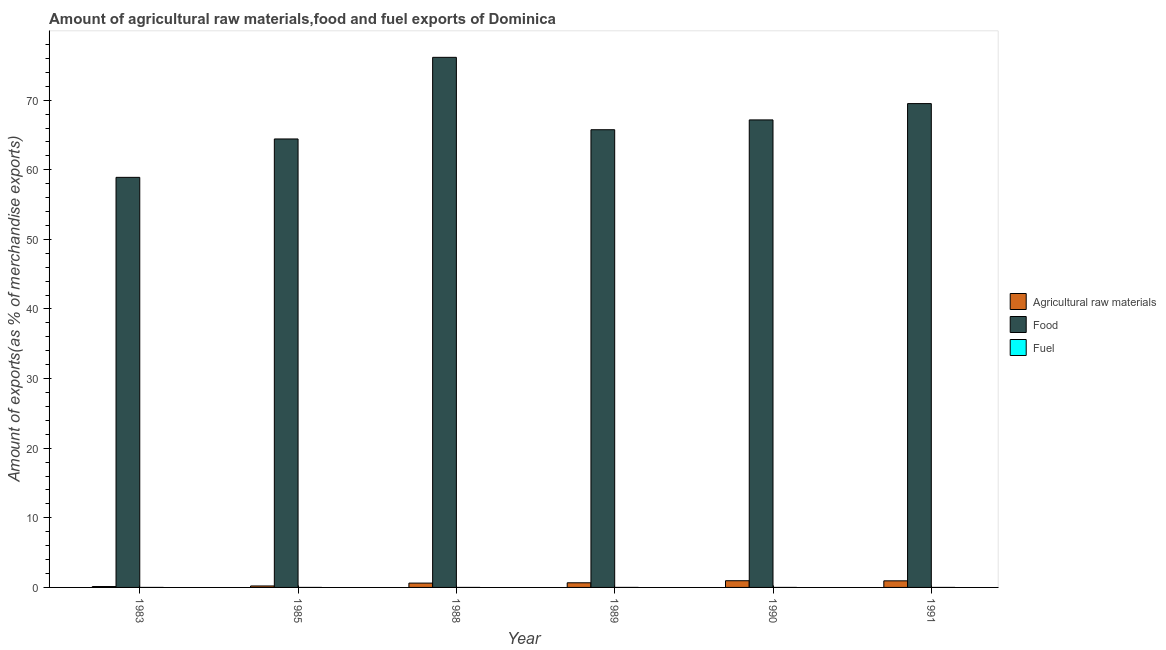How many different coloured bars are there?
Your response must be concise. 3. How many groups of bars are there?
Offer a terse response. 6. Are the number of bars on each tick of the X-axis equal?
Keep it short and to the point. Yes. How many bars are there on the 1st tick from the right?
Your answer should be compact. 3. What is the label of the 4th group of bars from the left?
Provide a short and direct response. 1989. What is the percentage of food exports in 1985?
Your answer should be compact. 64.43. Across all years, what is the maximum percentage of fuel exports?
Ensure brevity in your answer.  0. Across all years, what is the minimum percentage of fuel exports?
Offer a terse response. 3.92247456525302e-6. In which year was the percentage of fuel exports maximum?
Provide a short and direct response. 1989. In which year was the percentage of food exports minimum?
Your response must be concise. 1983. What is the total percentage of fuel exports in the graph?
Keep it short and to the point. 0. What is the difference between the percentage of food exports in 1983 and that in 1985?
Offer a terse response. -5.51. What is the difference between the percentage of raw materials exports in 1985 and the percentage of fuel exports in 1988?
Your answer should be very brief. -0.41. What is the average percentage of food exports per year?
Offer a terse response. 66.99. What is the ratio of the percentage of food exports in 1985 to that in 1991?
Make the answer very short. 0.93. What is the difference between the highest and the second highest percentage of raw materials exports?
Offer a terse response. 0.02. What is the difference between the highest and the lowest percentage of raw materials exports?
Give a very brief answer. 0.83. In how many years, is the percentage of raw materials exports greater than the average percentage of raw materials exports taken over all years?
Your answer should be very brief. 4. Is the sum of the percentage of raw materials exports in 1985 and 1989 greater than the maximum percentage of food exports across all years?
Your answer should be very brief. No. What does the 3rd bar from the left in 1991 represents?
Provide a succinct answer. Fuel. What does the 2nd bar from the right in 1988 represents?
Your answer should be compact. Food. Is it the case that in every year, the sum of the percentage of raw materials exports and percentage of food exports is greater than the percentage of fuel exports?
Your response must be concise. Yes. What is the difference between two consecutive major ticks on the Y-axis?
Give a very brief answer. 10. Does the graph contain grids?
Your answer should be compact. No. What is the title of the graph?
Ensure brevity in your answer.  Amount of agricultural raw materials,food and fuel exports of Dominica. What is the label or title of the Y-axis?
Give a very brief answer. Amount of exports(as % of merchandise exports). What is the Amount of exports(as % of merchandise exports) in Agricultural raw materials in 1983?
Ensure brevity in your answer.  0.13. What is the Amount of exports(as % of merchandise exports) in Food in 1983?
Your answer should be very brief. 58.91. What is the Amount of exports(as % of merchandise exports) of Fuel in 1983?
Your answer should be very brief. 0. What is the Amount of exports(as % of merchandise exports) of Agricultural raw materials in 1985?
Ensure brevity in your answer.  0.21. What is the Amount of exports(as % of merchandise exports) of Food in 1985?
Make the answer very short. 64.43. What is the Amount of exports(as % of merchandise exports) of Fuel in 1985?
Your answer should be very brief. 3.67117277885959e-5. What is the Amount of exports(as % of merchandise exports) in Agricultural raw materials in 1988?
Offer a terse response. 0.62. What is the Amount of exports(as % of merchandise exports) in Food in 1988?
Your answer should be very brief. 76.16. What is the Amount of exports(as % of merchandise exports) of Fuel in 1988?
Give a very brief answer. 0. What is the Amount of exports(as % of merchandise exports) in Agricultural raw materials in 1989?
Provide a succinct answer. 0.67. What is the Amount of exports(as % of merchandise exports) of Food in 1989?
Provide a succinct answer. 65.75. What is the Amount of exports(as % of merchandise exports) of Fuel in 1989?
Give a very brief answer. 0. What is the Amount of exports(as % of merchandise exports) of Agricultural raw materials in 1990?
Provide a short and direct response. 0.96. What is the Amount of exports(as % of merchandise exports) of Food in 1990?
Ensure brevity in your answer.  67.17. What is the Amount of exports(as % of merchandise exports) of Fuel in 1990?
Provide a short and direct response. 0. What is the Amount of exports(as % of merchandise exports) of Agricultural raw materials in 1991?
Your answer should be compact. 0.95. What is the Amount of exports(as % of merchandise exports) of Food in 1991?
Ensure brevity in your answer.  69.51. What is the Amount of exports(as % of merchandise exports) of Fuel in 1991?
Ensure brevity in your answer.  3.92247456525302e-6. Across all years, what is the maximum Amount of exports(as % of merchandise exports) of Agricultural raw materials?
Offer a terse response. 0.96. Across all years, what is the maximum Amount of exports(as % of merchandise exports) of Food?
Provide a succinct answer. 76.16. Across all years, what is the maximum Amount of exports(as % of merchandise exports) in Fuel?
Offer a terse response. 0. Across all years, what is the minimum Amount of exports(as % of merchandise exports) in Agricultural raw materials?
Keep it short and to the point. 0.13. Across all years, what is the minimum Amount of exports(as % of merchandise exports) of Food?
Provide a short and direct response. 58.91. Across all years, what is the minimum Amount of exports(as % of merchandise exports) in Fuel?
Your answer should be compact. 3.92247456525302e-6. What is the total Amount of exports(as % of merchandise exports) in Agricultural raw materials in the graph?
Keep it short and to the point. 3.54. What is the total Amount of exports(as % of merchandise exports) in Food in the graph?
Ensure brevity in your answer.  401.92. What is the total Amount of exports(as % of merchandise exports) of Fuel in the graph?
Offer a very short reply. 0. What is the difference between the Amount of exports(as % of merchandise exports) in Agricultural raw materials in 1983 and that in 1985?
Your answer should be very brief. -0.08. What is the difference between the Amount of exports(as % of merchandise exports) of Food in 1983 and that in 1985?
Give a very brief answer. -5.51. What is the difference between the Amount of exports(as % of merchandise exports) in Agricultural raw materials in 1983 and that in 1988?
Keep it short and to the point. -0.49. What is the difference between the Amount of exports(as % of merchandise exports) of Food in 1983 and that in 1988?
Offer a very short reply. -17.24. What is the difference between the Amount of exports(as % of merchandise exports) in Fuel in 1983 and that in 1988?
Give a very brief answer. 0. What is the difference between the Amount of exports(as % of merchandise exports) in Agricultural raw materials in 1983 and that in 1989?
Provide a short and direct response. -0.54. What is the difference between the Amount of exports(as % of merchandise exports) of Food in 1983 and that in 1989?
Your response must be concise. -6.84. What is the difference between the Amount of exports(as % of merchandise exports) of Fuel in 1983 and that in 1989?
Ensure brevity in your answer.  -0. What is the difference between the Amount of exports(as % of merchandise exports) in Agricultural raw materials in 1983 and that in 1990?
Offer a terse response. -0.83. What is the difference between the Amount of exports(as % of merchandise exports) of Food in 1983 and that in 1990?
Offer a terse response. -8.25. What is the difference between the Amount of exports(as % of merchandise exports) of Agricultural raw materials in 1983 and that in 1991?
Provide a succinct answer. -0.82. What is the difference between the Amount of exports(as % of merchandise exports) of Food in 1983 and that in 1991?
Offer a terse response. -10.59. What is the difference between the Amount of exports(as % of merchandise exports) in Agricultural raw materials in 1985 and that in 1988?
Give a very brief answer. -0.41. What is the difference between the Amount of exports(as % of merchandise exports) of Food in 1985 and that in 1988?
Your answer should be very brief. -11.73. What is the difference between the Amount of exports(as % of merchandise exports) of Fuel in 1985 and that in 1988?
Give a very brief answer. -0. What is the difference between the Amount of exports(as % of merchandise exports) in Agricultural raw materials in 1985 and that in 1989?
Your answer should be compact. -0.46. What is the difference between the Amount of exports(as % of merchandise exports) of Food in 1985 and that in 1989?
Provide a succinct answer. -1.33. What is the difference between the Amount of exports(as % of merchandise exports) of Fuel in 1985 and that in 1989?
Offer a very short reply. -0. What is the difference between the Amount of exports(as % of merchandise exports) in Agricultural raw materials in 1985 and that in 1990?
Make the answer very short. -0.75. What is the difference between the Amount of exports(as % of merchandise exports) of Food in 1985 and that in 1990?
Provide a succinct answer. -2.74. What is the difference between the Amount of exports(as % of merchandise exports) of Fuel in 1985 and that in 1990?
Your answer should be compact. -0. What is the difference between the Amount of exports(as % of merchandise exports) of Agricultural raw materials in 1985 and that in 1991?
Offer a very short reply. -0.74. What is the difference between the Amount of exports(as % of merchandise exports) in Food in 1985 and that in 1991?
Offer a very short reply. -5.08. What is the difference between the Amount of exports(as % of merchandise exports) in Agricultural raw materials in 1988 and that in 1989?
Make the answer very short. -0.05. What is the difference between the Amount of exports(as % of merchandise exports) of Food in 1988 and that in 1989?
Provide a short and direct response. 10.4. What is the difference between the Amount of exports(as % of merchandise exports) in Fuel in 1988 and that in 1989?
Your response must be concise. -0. What is the difference between the Amount of exports(as % of merchandise exports) in Agricultural raw materials in 1988 and that in 1990?
Ensure brevity in your answer.  -0.34. What is the difference between the Amount of exports(as % of merchandise exports) in Food in 1988 and that in 1990?
Your answer should be very brief. 8.99. What is the difference between the Amount of exports(as % of merchandise exports) of Fuel in 1988 and that in 1990?
Provide a short and direct response. 0. What is the difference between the Amount of exports(as % of merchandise exports) of Agricultural raw materials in 1988 and that in 1991?
Ensure brevity in your answer.  -0.32. What is the difference between the Amount of exports(as % of merchandise exports) in Food in 1988 and that in 1991?
Offer a terse response. 6.65. What is the difference between the Amount of exports(as % of merchandise exports) of Agricultural raw materials in 1989 and that in 1990?
Provide a succinct answer. -0.3. What is the difference between the Amount of exports(as % of merchandise exports) in Food in 1989 and that in 1990?
Your answer should be very brief. -1.41. What is the difference between the Amount of exports(as % of merchandise exports) in Fuel in 1989 and that in 1990?
Your response must be concise. 0. What is the difference between the Amount of exports(as % of merchandise exports) of Agricultural raw materials in 1989 and that in 1991?
Offer a very short reply. -0.28. What is the difference between the Amount of exports(as % of merchandise exports) in Food in 1989 and that in 1991?
Your answer should be compact. -3.75. What is the difference between the Amount of exports(as % of merchandise exports) in Fuel in 1989 and that in 1991?
Your answer should be compact. 0. What is the difference between the Amount of exports(as % of merchandise exports) of Agricultural raw materials in 1990 and that in 1991?
Make the answer very short. 0.02. What is the difference between the Amount of exports(as % of merchandise exports) of Food in 1990 and that in 1991?
Provide a succinct answer. -2.34. What is the difference between the Amount of exports(as % of merchandise exports) in Agricultural raw materials in 1983 and the Amount of exports(as % of merchandise exports) in Food in 1985?
Make the answer very short. -64.3. What is the difference between the Amount of exports(as % of merchandise exports) of Agricultural raw materials in 1983 and the Amount of exports(as % of merchandise exports) of Fuel in 1985?
Ensure brevity in your answer.  0.13. What is the difference between the Amount of exports(as % of merchandise exports) in Food in 1983 and the Amount of exports(as % of merchandise exports) in Fuel in 1985?
Offer a terse response. 58.91. What is the difference between the Amount of exports(as % of merchandise exports) in Agricultural raw materials in 1983 and the Amount of exports(as % of merchandise exports) in Food in 1988?
Offer a terse response. -76.02. What is the difference between the Amount of exports(as % of merchandise exports) in Agricultural raw materials in 1983 and the Amount of exports(as % of merchandise exports) in Fuel in 1988?
Your answer should be compact. 0.13. What is the difference between the Amount of exports(as % of merchandise exports) in Food in 1983 and the Amount of exports(as % of merchandise exports) in Fuel in 1988?
Ensure brevity in your answer.  58.91. What is the difference between the Amount of exports(as % of merchandise exports) in Agricultural raw materials in 1983 and the Amount of exports(as % of merchandise exports) in Food in 1989?
Give a very brief answer. -65.62. What is the difference between the Amount of exports(as % of merchandise exports) in Agricultural raw materials in 1983 and the Amount of exports(as % of merchandise exports) in Fuel in 1989?
Ensure brevity in your answer.  0.13. What is the difference between the Amount of exports(as % of merchandise exports) of Food in 1983 and the Amount of exports(as % of merchandise exports) of Fuel in 1989?
Your answer should be very brief. 58.91. What is the difference between the Amount of exports(as % of merchandise exports) of Agricultural raw materials in 1983 and the Amount of exports(as % of merchandise exports) of Food in 1990?
Your answer should be very brief. -67.03. What is the difference between the Amount of exports(as % of merchandise exports) in Agricultural raw materials in 1983 and the Amount of exports(as % of merchandise exports) in Fuel in 1990?
Offer a very short reply. 0.13. What is the difference between the Amount of exports(as % of merchandise exports) of Food in 1983 and the Amount of exports(as % of merchandise exports) of Fuel in 1990?
Make the answer very short. 58.91. What is the difference between the Amount of exports(as % of merchandise exports) of Agricultural raw materials in 1983 and the Amount of exports(as % of merchandise exports) of Food in 1991?
Give a very brief answer. -69.38. What is the difference between the Amount of exports(as % of merchandise exports) in Agricultural raw materials in 1983 and the Amount of exports(as % of merchandise exports) in Fuel in 1991?
Give a very brief answer. 0.13. What is the difference between the Amount of exports(as % of merchandise exports) of Food in 1983 and the Amount of exports(as % of merchandise exports) of Fuel in 1991?
Provide a succinct answer. 58.91. What is the difference between the Amount of exports(as % of merchandise exports) in Agricultural raw materials in 1985 and the Amount of exports(as % of merchandise exports) in Food in 1988?
Provide a short and direct response. -75.94. What is the difference between the Amount of exports(as % of merchandise exports) of Agricultural raw materials in 1985 and the Amount of exports(as % of merchandise exports) of Fuel in 1988?
Make the answer very short. 0.21. What is the difference between the Amount of exports(as % of merchandise exports) of Food in 1985 and the Amount of exports(as % of merchandise exports) of Fuel in 1988?
Keep it short and to the point. 64.43. What is the difference between the Amount of exports(as % of merchandise exports) of Agricultural raw materials in 1985 and the Amount of exports(as % of merchandise exports) of Food in 1989?
Ensure brevity in your answer.  -65.54. What is the difference between the Amount of exports(as % of merchandise exports) in Agricultural raw materials in 1985 and the Amount of exports(as % of merchandise exports) in Fuel in 1989?
Provide a short and direct response. 0.21. What is the difference between the Amount of exports(as % of merchandise exports) of Food in 1985 and the Amount of exports(as % of merchandise exports) of Fuel in 1989?
Keep it short and to the point. 64.43. What is the difference between the Amount of exports(as % of merchandise exports) of Agricultural raw materials in 1985 and the Amount of exports(as % of merchandise exports) of Food in 1990?
Your answer should be compact. -66.95. What is the difference between the Amount of exports(as % of merchandise exports) in Agricultural raw materials in 1985 and the Amount of exports(as % of merchandise exports) in Fuel in 1990?
Offer a terse response. 0.21. What is the difference between the Amount of exports(as % of merchandise exports) of Food in 1985 and the Amount of exports(as % of merchandise exports) of Fuel in 1990?
Ensure brevity in your answer.  64.43. What is the difference between the Amount of exports(as % of merchandise exports) of Agricultural raw materials in 1985 and the Amount of exports(as % of merchandise exports) of Food in 1991?
Provide a succinct answer. -69.3. What is the difference between the Amount of exports(as % of merchandise exports) of Agricultural raw materials in 1985 and the Amount of exports(as % of merchandise exports) of Fuel in 1991?
Offer a terse response. 0.21. What is the difference between the Amount of exports(as % of merchandise exports) in Food in 1985 and the Amount of exports(as % of merchandise exports) in Fuel in 1991?
Make the answer very short. 64.43. What is the difference between the Amount of exports(as % of merchandise exports) of Agricultural raw materials in 1988 and the Amount of exports(as % of merchandise exports) of Food in 1989?
Offer a very short reply. -65.13. What is the difference between the Amount of exports(as % of merchandise exports) in Agricultural raw materials in 1988 and the Amount of exports(as % of merchandise exports) in Fuel in 1989?
Your answer should be compact. 0.62. What is the difference between the Amount of exports(as % of merchandise exports) of Food in 1988 and the Amount of exports(as % of merchandise exports) of Fuel in 1989?
Offer a terse response. 76.15. What is the difference between the Amount of exports(as % of merchandise exports) in Agricultural raw materials in 1988 and the Amount of exports(as % of merchandise exports) in Food in 1990?
Offer a terse response. -66.54. What is the difference between the Amount of exports(as % of merchandise exports) of Agricultural raw materials in 1988 and the Amount of exports(as % of merchandise exports) of Fuel in 1990?
Ensure brevity in your answer.  0.62. What is the difference between the Amount of exports(as % of merchandise exports) of Food in 1988 and the Amount of exports(as % of merchandise exports) of Fuel in 1990?
Ensure brevity in your answer.  76.16. What is the difference between the Amount of exports(as % of merchandise exports) in Agricultural raw materials in 1988 and the Amount of exports(as % of merchandise exports) in Food in 1991?
Give a very brief answer. -68.89. What is the difference between the Amount of exports(as % of merchandise exports) in Agricultural raw materials in 1988 and the Amount of exports(as % of merchandise exports) in Fuel in 1991?
Your answer should be compact. 0.62. What is the difference between the Amount of exports(as % of merchandise exports) of Food in 1988 and the Amount of exports(as % of merchandise exports) of Fuel in 1991?
Offer a terse response. 76.16. What is the difference between the Amount of exports(as % of merchandise exports) of Agricultural raw materials in 1989 and the Amount of exports(as % of merchandise exports) of Food in 1990?
Ensure brevity in your answer.  -66.5. What is the difference between the Amount of exports(as % of merchandise exports) in Agricultural raw materials in 1989 and the Amount of exports(as % of merchandise exports) in Fuel in 1990?
Give a very brief answer. 0.67. What is the difference between the Amount of exports(as % of merchandise exports) in Food in 1989 and the Amount of exports(as % of merchandise exports) in Fuel in 1990?
Offer a terse response. 65.75. What is the difference between the Amount of exports(as % of merchandise exports) of Agricultural raw materials in 1989 and the Amount of exports(as % of merchandise exports) of Food in 1991?
Ensure brevity in your answer.  -68.84. What is the difference between the Amount of exports(as % of merchandise exports) of Agricultural raw materials in 1989 and the Amount of exports(as % of merchandise exports) of Fuel in 1991?
Provide a short and direct response. 0.67. What is the difference between the Amount of exports(as % of merchandise exports) of Food in 1989 and the Amount of exports(as % of merchandise exports) of Fuel in 1991?
Provide a succinct answer. 65.75. What is the difference between the Amount of exports(as % of merchandise exports) of Agricultural raw materials in 1990 and the Amount of exports(as % of merchandise exports) of Food in 1991?
Give a very brief answer. -68.55. What is the difference between the Amount of exports(as % of merchandise exports) of Agricultural raw materials in 1990 and the Amount of exports(as % of merchandise exports) of Fuel in 1991?
Provide a short and direct response. 0.96. What is the difference between the Amount of exports(as % of merchandise exports) in Food in 1990 and the Amount of exports(as % of merchandise exports) in Fuel in 1991?
Offer a very short reply. 67.17. What is the average Amount of exports(as % of merchandise exports) in Agricultural raw materials per year?
Give a very brief answer. 0.59. What is the average Amount of exports(as % of merchandise exports) of Food per year?
Your answer should be very brief. 66.99. What is the average Amount of exports(as % of merchandise exports) of Fuel per year?
Your response must be concise. 0. In the year 1983, what is the difference between the Amount of exports(as % of merchandise exports) of Agricultural raw materials and Amount of exports(as % of merchandise exports) of Food?
Give a very brief answer. -58.78. In the year 1983, what is the difference between the Amount of exports(as % of merchandise exports) of Agricultural raw materials and Amount of exports(as % of merchandise exports) of Fuel?
Your answer should be compact. 0.13. In the year 1983, what is the difference between the Amount of exports(as % of merchandise exports) in Food and Amount of exports(as % of merchandise exports) in Fuel?
Your answer should be compact. 58.91. In the year 1985, what is the difference between the Amount of exports(as % of merchandise exports) of Agricultural raw materials and Amount of exports(as % of merchandise exports) of Food?
Give a very brief answer. -64.22. In the year 1985, what is the difference between the Amount of exports(as % of merchandise exports) in Agricultural raw materials and Amount of exports(as % of merchandise exports) in Fuel?
Give a very brief answer. 0.21. In the year 1985, what is the difference between the Amount of exports(as % of merchandise exports) of Food and Amount of exports(as % of merchandise exports) of Fuel?
Provide a succinct answer. 64.43. In the year 1988, what is the difference between the Amount of exports(as % of merchandise exports) of Agricultural raw materials and Amount of exports(as % of merchandise exports) of Food?
Give a very brief answer. -75.53. In the year 1988, what is the difference between the Amount of exports(as % of merchandise exports) of Agricultural raw materials and Amount of exports(as % of merchandise exports) of Fuel?
Give a very brief answer. 0.62. In the year 1988, what is the difference between the Amount of exports(as % of merchandise exports) in Food and Amount of exports(as % of merchandise exports) in Fuel?
Offer a very short reply. 76.16. In the year 1989, what is the difference between the Amount of exports(as % of merchandise exports) in Agricultural raw materials and Amount of exports(as % of merchandise exports) in Food?
Ensure brevity in your answer.  -65.09. In the year 1989, what is the difference between the Amount of exports(as % of merchandise exports) of Agricultural raw materials and Amount of exports(as % of merchandise exports) of Fuel?
Provide a short and direct response. 0.67. In the year 1989, what is the difference between the Amount of exports(as % of merchandise exports) in Food and Amount of exports(as % of merchandise exports) in Fuel?
Provide a succinct answer. 65.75. In the year 1990, what is the difference between the Amount of exports(as % of merchandise exports) of Agricultural raw materials and Amount of exports(as % of merchandise exports) of Food?
Your response must be concise. -66.2. In the year 1990, what is the difference between the Amount of exports(as % of merchandise exports) of Agricultural raw materials and Amount of exports(as % of merchandise exports) of Fuel?
Provide a succinct answer. 0.96. In the year 1990, what is the difference between the Amount of exports(as % of merchandise exports) in Food and Amount of exports(as % of merchandise exports) in Fuel?
Provide a succinct answer. 67.17. In the year 1991, what is the difference between the Amount of exports(as % of merchandise exports) of Agricultural raw materials and Amount of exports(as % of merchandise exports) of Food?
Your answer should be compact. -68.56. In the year 1991, what is the difference between the Amount of exports(as % of merchandise exports) in Agricultural raw materials and Amount of exports(as % of merchandise exports) in Fuel?
Your answer should be compact. 0.95. In the year 1991, what is the difference between the Amount of exports(as % of merchandise exports) of Food and Amount of exports(as % of merchandise exports) of Fuel?
Ensure brevity in your answer.  69.51. What is the ratio of the Amount of exports(as % of merchandise exports) of Agricultural raw materials in 1983 to that in 1985?
Ensure brevity in your answer.  0.62. What is the ratio of the Amount of exports(as % of merchandise exports) of Food in 1983 to that in 1985?
Provide a short and direct response. 0.91. What is the ratio of the Amount of exports(as % of merchandise exports) in Fuel in 1983 to that in 1985?
Your answer should be compact. 8.75. What is the ratio of the Amount of exports(as % of merchandise exports) in Agricultural raw materials in 1983 to that in 1988?
Provide a succinct answer. 0.21. What is the ratio of the Amount of exports(as % of merchandise exports) of Food in 1983 to that in 1988?
Give a very brief answer. 0.77. What is the ratio of the Amount of exports(as % of merchandise exports) of Fuel in 1983 to that in 1988?
Make the answer very short. 1.34. What is the ratio of the Amount of exports(as % of merchandise exports) of Agricultural raw materials in 1983 to that in 1989?
Your answer should be compact. 0.2. What is the ratio of the Amount of exports(as % of merchandise exports) in Food in 1983 to that in 1989?
Offer a very short reply. 0.9. What is the ratio of the Amount of exports(as % of merchandise exports) in Fuel in 1983 to that in 1989?
Your answer should be compact. 0.37. What is the ratio of the Amount of exports(as % of merchandise exports) in Agricultural raw materials in 1983 to that in 1990?
Offer a very short reply. 0.14. What is the ratio of the Amount of exports(as % of merchandise exports) of Food in 1983 to that in 1990?
Offer a very short reply. 0.88. What is the ratio of the Amount of exports(as % of merchandise exports) in Fuel in 1983 to that in 1990?
Give a very brief answer. 2.98. What is the ratio of the Amount of exports(as % of merchandise exports) in Agricultural raw materials in 1983 to that in 1991?
Your answer should be very brief. 0.14. What is the ratio of the Amount of exports(as % of merchandise exports) of Food in 1983 to that in 1991?
Offer a terse response. 0.85. What is the ratio of the Amount of exports(as % of merchandise exports) in Fuel in 1983 to that in 1991?
Provide a short and direct response. 81.85. What is the ratio of the Amount of exports(as % of merchandise exports) in Agricultural raw materials in 1985 to that in 1988?
Keep it short and to the point. 0.34. What is the ratio of the Amount of exports(as % of merchandise exports) of Food in 1985 to that in 1988?
Make the answer very short. 0.85. What is the ratio of the Amount of exports(as % of merchandise exports) in Fuel in 1985 to that in 1988?
Offer a terse response. 0.15. What is the ratio of the Amount of exports(as % of merchandise exports) of Agricultural raw materials in 1985 to that in 1989?
Your answer should be very brief. 0.32. What is the ratio of the Amount of exports(as % of merchandise exports) of Food in 1985 to that in 1989?
Make the answer very short. 0.98. What is the ratio of the Amount of exports(as % of merchandise exports) of Fuel in 1985 to that in 1989?
Provide a succinct answer. 0.04. What is the ratio of the Amount of exports(as % of merchandise exports) in Agricultural raw materials in 1985 to that in 1990?
Make the answer very short. 0.22. What is the ratio of the Amount of exports(as % of merchandise exports) of Food in 1985 to that in 1990?
Ensure brevity in your answer.  0.96. What is the ratio of the Amount of exports(as % of merchandise exports) of Fuel in 1985 to that in 1990?
Keep it short and to the point. 0.34. What is the ratio of the Amount of exports(as % of merchandise exports) in Agricultural raw materials in 1985 to that in 1991?
Make the answer very short. 0.22. What is the ratio of the Amount of exports(as % of merchandise exports) of Food in 1985 to that in 1991?
Ensure brevity in your answer.  0.93. What is the ratio of the Amount of exports(as % of merchandise exports) in Fuel in 1985 to that in 1991?
Ensure brevity in your answer.  9.36. What is the ratio of the Amount of exports(as % of merchandise exports) of Agricultural raw materials in 1988 to that in 1989?
Provide a succinct answer. 0.93. What is the ratio of the Amount of exports(as % of merchandise exports) of Food in 1988 to that in 1989?
Your answer should be very brief. 1.16. What is the ratio of the Amount of exports(as % of merchandise exports) in Fuel in 1988 to that in 1989?
Offer a very short reply. 0.27. What is the ratio of the Amount of exports(as % of merchandise exports) in Agricultural raw materials in 1988 to that in 1990?
Your answer should be very brief. 0.65. What is the ratio of the Amount of exports(as % of merchandise exports) in Food in 1988 to that in 1990?
Provide a succinct answer. 1.13. What is the ratio of the Amount of exports(as % of merchandise exports) of Fuel in 1988 to that in 1990?
Offer a very short reply. 2.22. What is the ratio of the Amount of exports(as % of merchandise exports) in Agricultural raw materials in 1988 to that in 1991?
Provide a succinct answer. 0.66. What is the ratio of the Amount of exports(as % of merchandise exports) in Food in 1988 to that in 1991?
Provide a succinct answer. 1.1. What is the ratio of the Amount of exports(as % of merchandise exports) of Fuel in 1988 to that in 1991?
Provide a short and direct response. 60.91. What is the ratio of the Amount of exports(as % of merchandise exports) of Agricultural raw materials in 1989 to that in 1990?
Provide a succinct answer. 0.69. What is the ratio of the Amount of exports(as % of merchandise exports) of Food in 1989 to that in 1990?
Make the answer very short. 0.98. What is the ratio of the Amount of exports(as % of merchandise exports) of Fuel in 1989 to that in 1990?
Keep it short and to the point. 8.17. What is the ratio of the Amount of exports(as % of merchandise exports) of Agricultural raw materials in 1989 to that in 1991?
Your response must be concise. 0.71. What is the ratio of the Amount of exports(as % of merchandise exports) of Food in 1989 to that in 1991?
Offer a terse response. 0.95. What is the ratio of the Amount of exports(as % of merchandise exports) in Fuel in 1989 to that in 1991?
Your answer should be compact. 224.16. What is the ratio of the Amount of exports(as % of merchandise exports) of Agricultural raw materials in 1990 to that in 1991?
Your answer should be very brief. 1.02. What is the ratio of the Amount of exports(as % of merchandise exports) in Food in 1990 to that in 1991?
Ensure brevity in your answer.  0.97. What is the ratio of the Amount of exports(as % of merchandise exports) in Fuel in 1990 to that in 1991?
Provide a short and direct response. 27.43. What is the difference between the highest and the second highest Amount of exports(as % of merchandise exports) in Agricultural raw materials?
Your answer should be very brief. 0.02. What is the difference between the highest and the second highest Amount of exports(as % of merchandise exports) in Food?
Offer a terse response. 6.65. What is the difference between the highest and the second highest Amount of exports(as % of merchandise exports) of Fuel?
Ensure brevity in your answer.  0. What is the difference between the highest and the lowest Amount of exports(as % of merchandise exports) in Agricultural raw materials?
Give a very brief answer. 0.83. What is the difference between the highest and the lowest Amount of exports(as % of merchandise exports) in Food?
Give a very brief answer. 17.24. What is the difference between the highest and the lowest Amount of exports(as % of merchandise exports) in Fuel?
Your response must be concise. 0. 